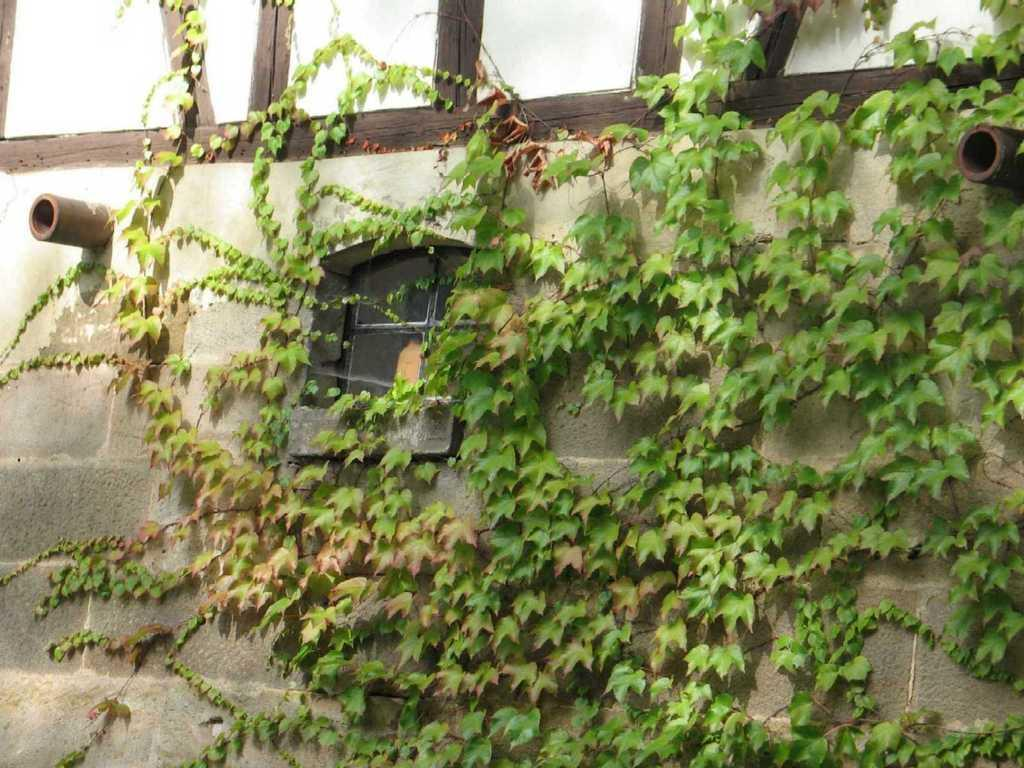What type of plants are growing on the wall in the image? There are creeper plants on a wall in the image. What other objects can be seen in the image? There are pipes visible in the image. What architectural feature is present in the image? There is a window in the image. What type of waste is visible in the image? There is no waste present in the image. What type of balloon can be seen floating in the image? There is no balloon present in the image. What type of gun can be seen in the image? There is no gun present in the image. 